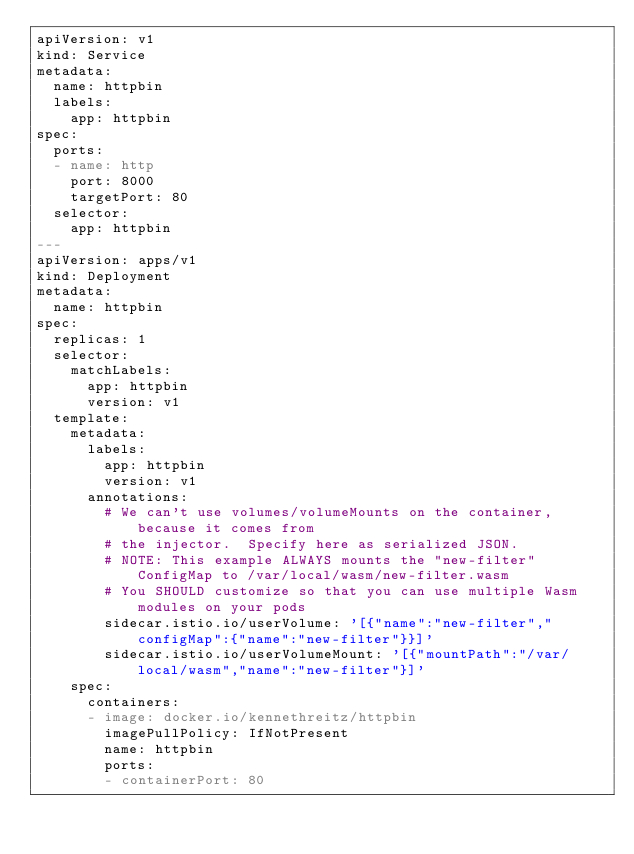Convert code to text. <code><loc_0><loc_0><loc_500><loc_500><_YAML_>apiVersion: v1
kind: Service
metadata:
  name: httpbin
  labels:
    app: httpbin
spec:
  ports:
  - name: http
    port: 8000
    targetPort: 80
  selector:
    app: httpbin
---
apiVersion: apps/v1
kind: Deployment
metadata:
  name: httpbin
spec:
  replicas: 1
  selector:
    matchLabels:
      app: httpbin
      version: v1
  template:
    metadata:
      labels:
        app: httpbin
        version: v1
      annotations:
        # We can't use volumes/volumeMounts on the container, because it comes from
        # the injector.  Specify here as serialized JSON.
        # NOTE: This example ALWAYS mounts the "new-filter" ConfigMap to /var/local/wasm/new-filter.wasm
        # You SHOULD customize so that you can use multiple Wasm modules on your pods
        sidecar.istio.io/userVolume: '[{"name":"new-filter","configMap":{"name":"new-filter"}}]'
        sidecar.istio.io/userVolumeMount: '[{"mountPath":"/var/local/wasm","name":"new-filter"}]'
    spec:
      containers:
      - image: docker.io/kennethreitz/httpbin
        imagePullPolicy: IfNotPresent
        name: httpbin
        ports:
        - containerPort: 80
</code> 